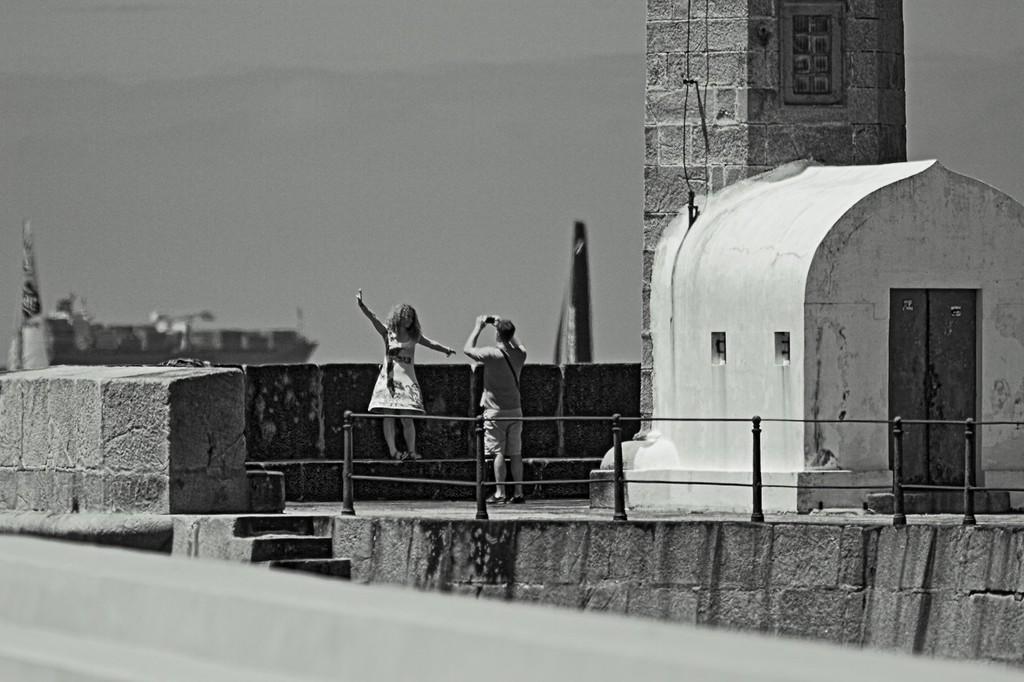Can you describe this image briefly? This is a black and white picture, in this image we can see two persons, among them one person is holding a camera and taking a picture of the other person, also we can see the stairs, doors, wall, railing and a shed, in the background we can see the sky. 